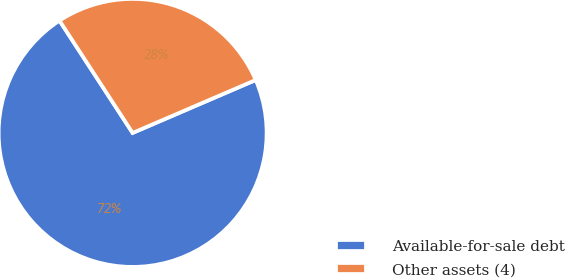Convert chart. <chart><loc_0><loc_0><loc_500><loc_500><pie_chart><fcel>Available-for-sale debt<fcel>Other assets (4)<nl><fcel>72.28%<fcel>27.72%<nl></chart> 